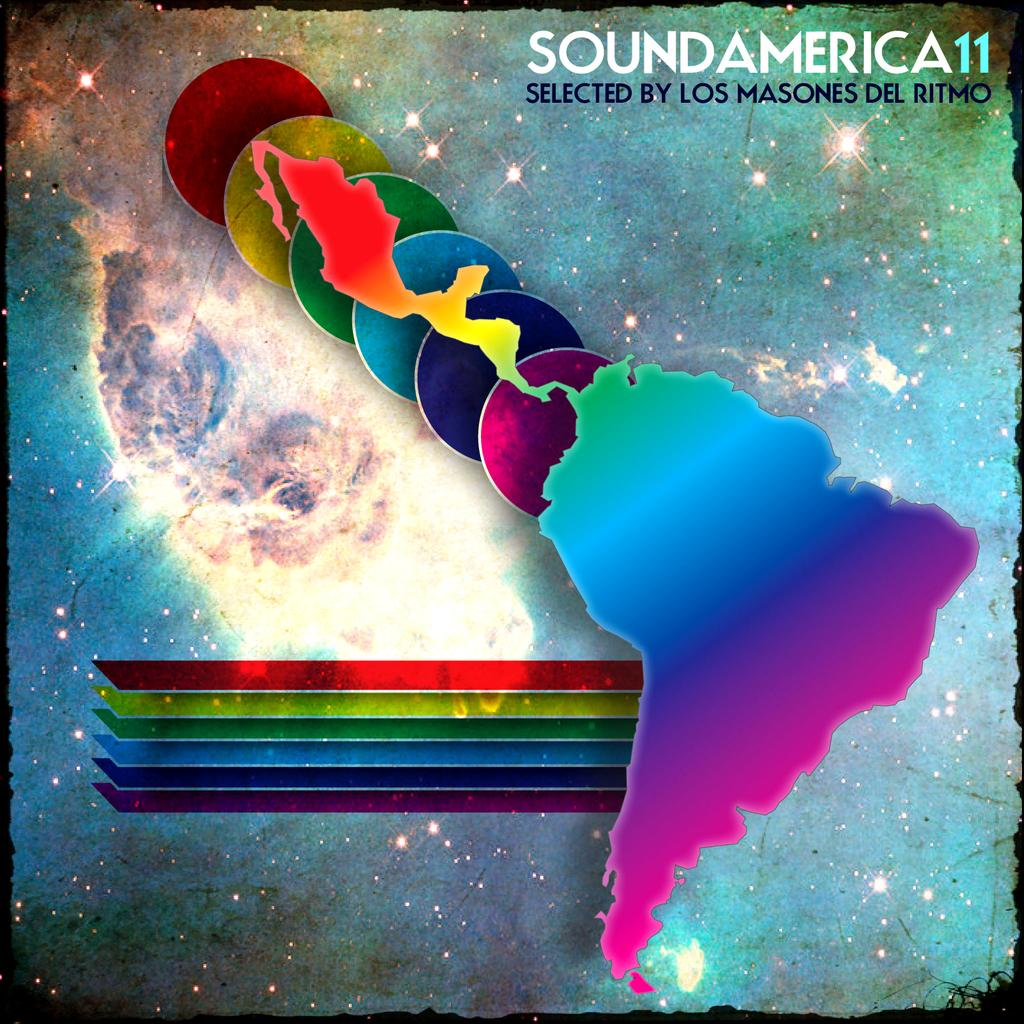<image>
Create a compact narrative representing the image presented. An album cover with the milkyway, planets, and countries on it and the words sound america. 